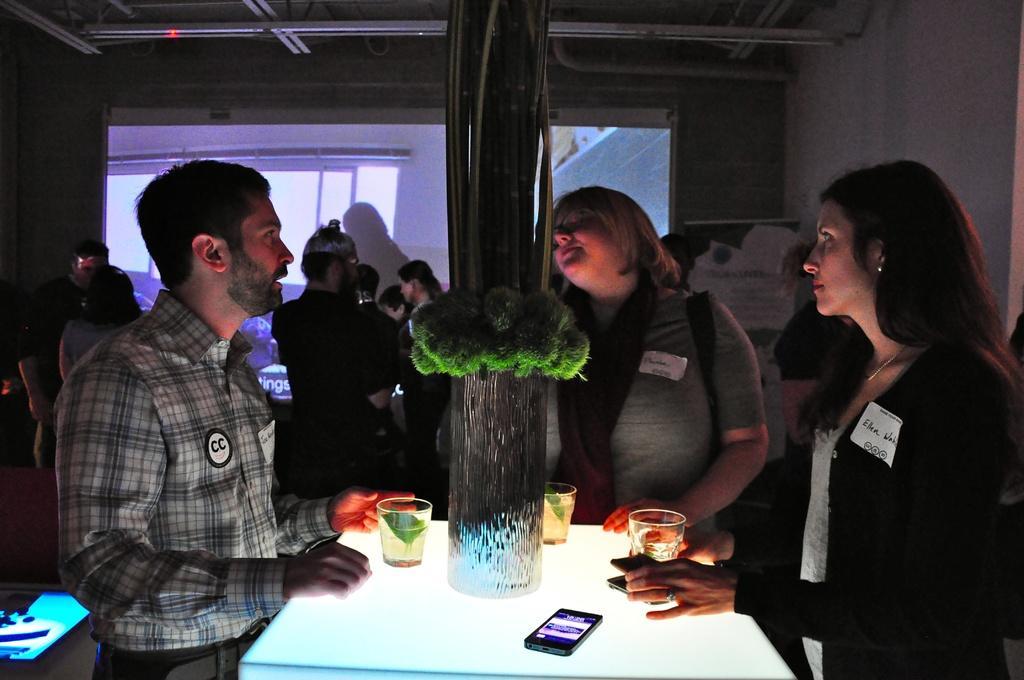Could you give a brief overview of what you see in this image? In this picture I can see there are three people standing and they are having drinks and there is a table in front of them and there are few others in the backdrop and there are few more people standing and there is a wall. 